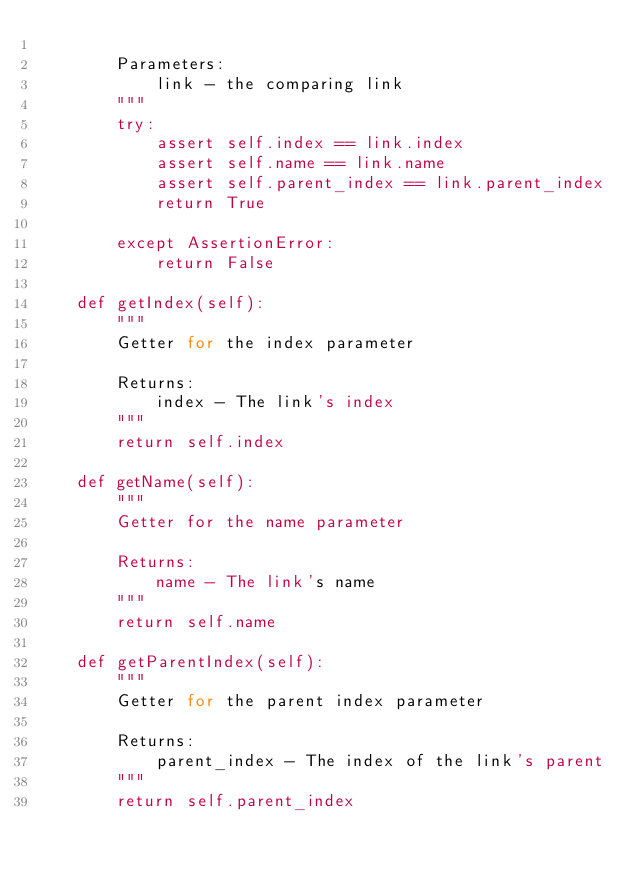<code> <loc_0><loc_0><loc_500><loc_500><_Python_>
        Parameters:
            link - the comparing link
        """
        try:
            assert self.index == link.index
            assert self.name == link.name
            assert self.parent_index == link.parent_index
            return True

        except AssertionError:
            return False

    def getIndex(self):
        """
        Getter for the index parameter

        Returns:
            index - The link's index
        """
        return self.index

    def getName(self):
        """
        Getter for the name parameter

        Returns:
            name - The link's name
        """
        return self.name

    def getParentIndex(self):
        """
        Getter for the parent index parameter

        Returns:
            parent_index - The index of the link's parent
        """
        return self.parent_index
</code> 